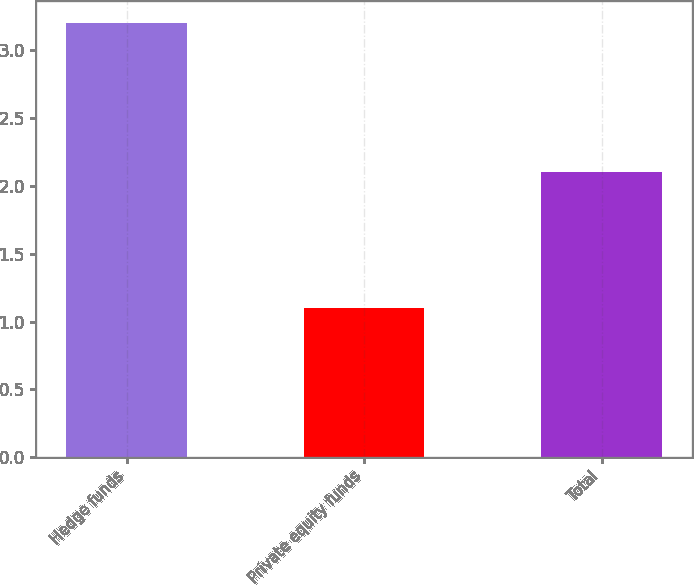<chart> <loc_0><loc_0><loc_500><loc_500><bar_chart><fcel>Hedge funds<fcel>Private equity funds<fcel>Total<nl><fcel>3.2<fcel>1.1<fcel>2.1<nl></chart> 